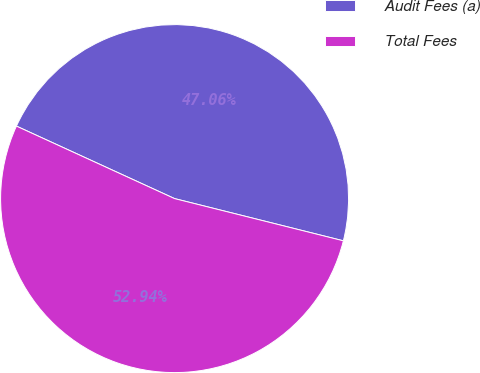Convert chart to OTSL. <chart><loc_0><loc_0><loc_500><loc_500><pie_chart><fcel>Audit Fees (a)<fcel>Total Fees<nl><fcel>47.06%<fcel>52.94%<nl></chart> 